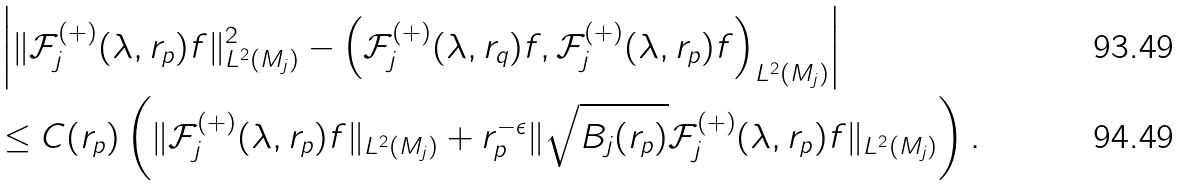<formula> <loc_0><loc_0><loc_500><loc_500>& \left | \| \mathcal { F } _ { j } ^ { ( + ) } ( \lambda , r _ { p } ) f \| ^ { 2 } _ { L ^ { 2 } ( M _ { j } ) } - \left ( \mathcal { F } _ { j } ^ { ( + ) } ( \lambda , r _ { q } ) f , \mathcal { F } _ { j } ^ { ( + ) } ( \lambda , r _ { p } ) f \right ) _ { L ^ { 2 } ( M _ { j } ) } \right | \\ & \leq C ( r _ { p } ) \left ( \| \mathcal { F } _ { j } ^ { ( + ) } ( \lambda , r _ { p } ) f \| _ { L ^ { 2 } ( M _ { j } ) } + r _ { p } ^ { - \epsilon } \| \sqrt { B _ { j } ( r _ { p } ) } \mathcal { F } _ { j } ^ { ( + ) } ( \lambda , r _ { p } ) f \| _ { L ^ { 2 } ( M _ { j } ) } \right ) .</formula> 